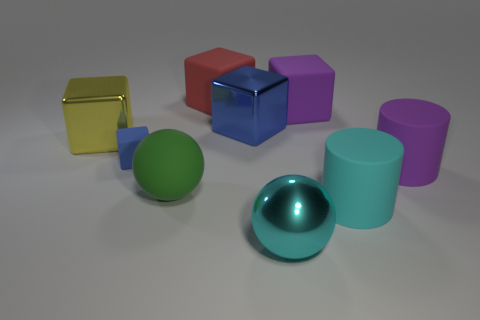Is the number of purple matte cylinders greater than the number of large purple things?
Offer a terse response. No. How many other objects are there of the same color as the matte ball?
Offer a terse response. 0. Does the large yellow cube have the same material as the thing that is right of the large cyan matte cylinder?
Provide a succinct answer. No. How many cyan things are in front of the big purple matte thing behind the large metallic cube to the right of the small matte cube?
Offer a very short reply. 2. Are there fewer large matte cylinders that are on the right side of the purple cylinder than large metallic cubes in front of the green matte object?
Ensure brevity in your answer.  No. What number of other things are the same material as the large yellow object?
Give a very brief answer. 2. There is a purple thing that is the same size as the purple cylinder; what material is it?
Your response must be concise. Rubber. What number of cyan objects are either small metal balls or cylinders?
Give a very brief answer. 1. There is a block that is on the right side of the small rubber thing and in front of the purple block; what color is it?
Offer a very short reply. Blue. Do the cube behind the big purple rubber block and the large purple object to the right of the cyan matte cylinder have the same material?
Ensure brevity in your answer.  Yes. 